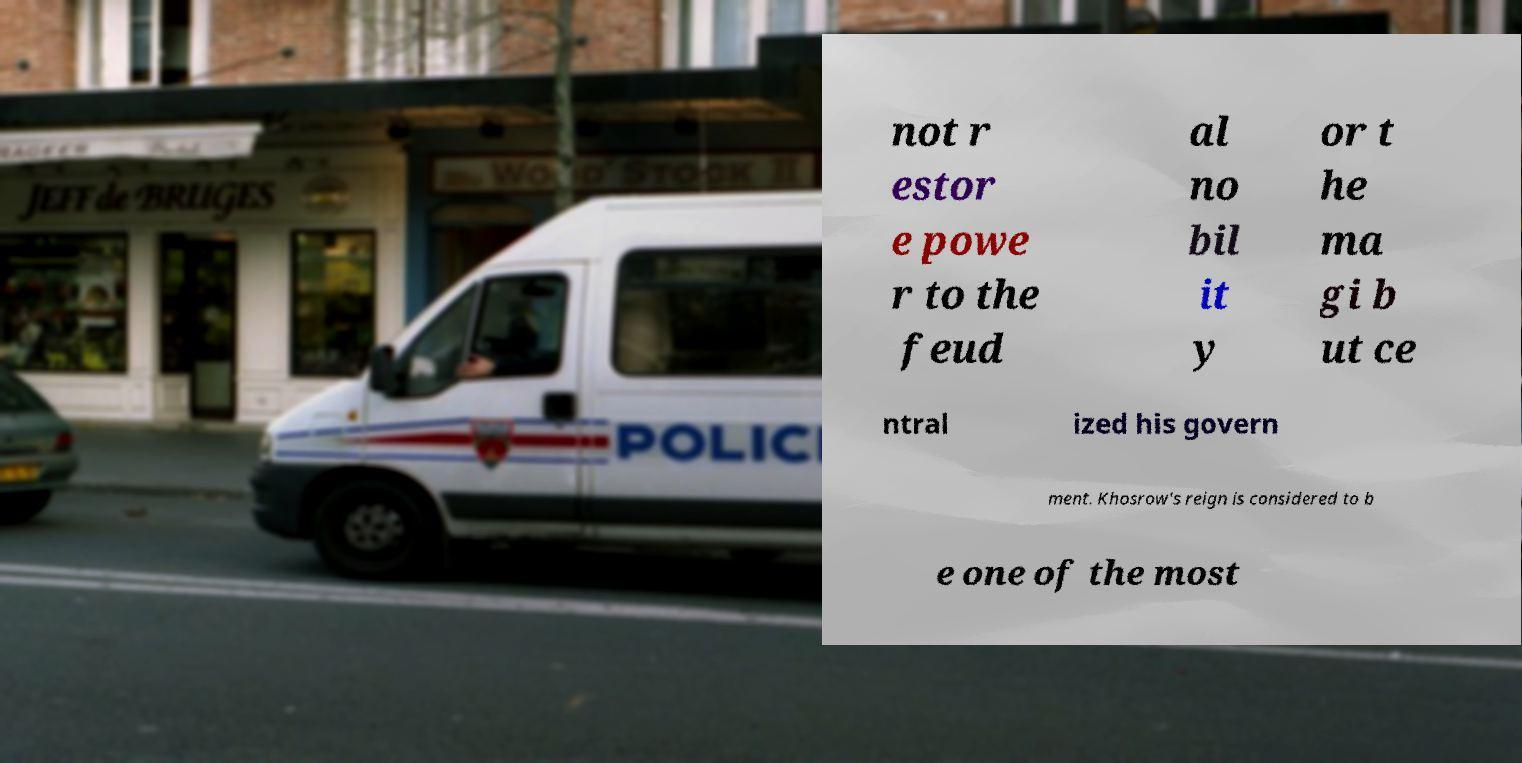Please identify and transcribe the text found in this image. not r estor e powe r to the feud al no bil it y or t he ma gi b ut ce ntral ized his govern ment. Khosrow's reign is considered to b e one of the most 